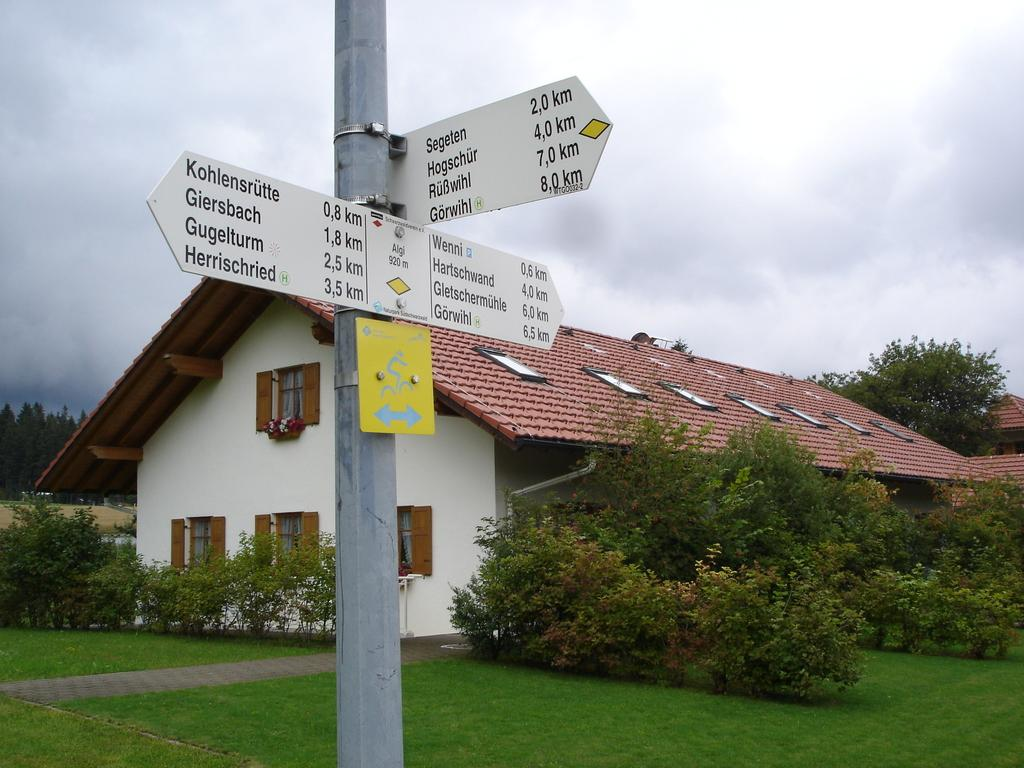<image>
Provide a brief description of the given image. the city of Segeten is on the white sign outside 